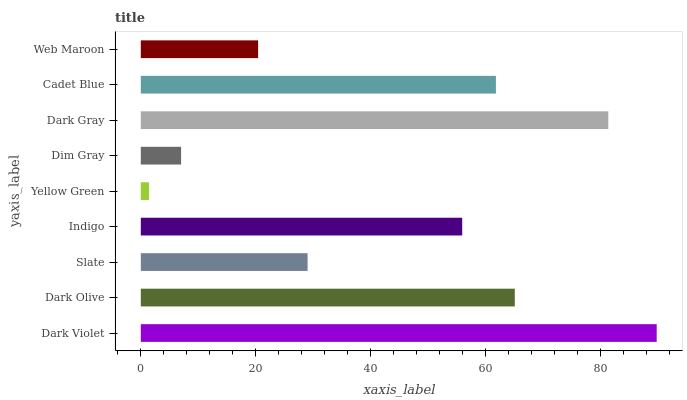Is Yellow Green the minimum?
Answer yes or no. Yes. Is Dark Violet the maximum?
Answer yes or no. Yes. Is Dark Olive the minimum?
Answer yes or no. No. Is Dark Olive the maximum?
Answer yes or no. No. Is Dark Violet greater than Dark Olive?
Answer yes or no. Yes. Is Dark Olive less than Dark Violet?
Answer yes or no. Yes. Is Dark Olive greater than Dark Violet?
Answer yes or no. No. Is Dark Violet less than Dark Olive?
Answer yes or no. No. Is Indigo the high median?
Answer yes or no. Yes. Is Indigo the low median?
Answer yes or no. Yes. Is Web Maroon the high median?
Answer yes or no. No. Is Yellow Green the low median?
Answer yes or no. No. 